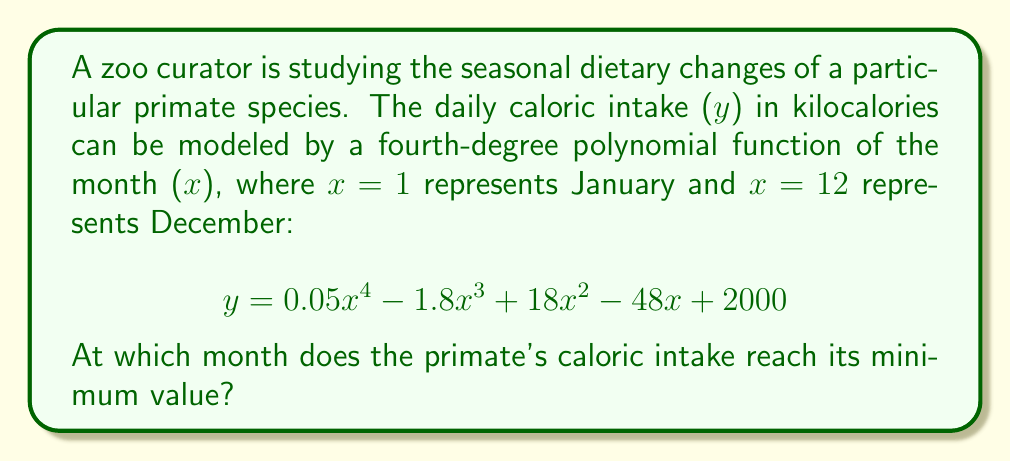Can you solve this math problem? To find the month when the caloric intake reaches its minimum, we need to follow these steps:

1) First, we need to find the derivative of the function:
   $$y' = 0.2x^3 - 5.4x^2 + 36x - 48$$

2) To find the critical points, we set y' = 0 and solve for x:
   $$0.2x^3 - 5.4x^2 + 36x - 48 = 0$$

3) This cubic equation is difficult to solve by hand, so we can use a graphing calculator or computer algebra system to find the roots. The roots are approximately:
   x ≈ 1.37, 5.62, and 20.01

4) Since we're only concerned with months 1-12, we can discard the solution 20.01.

5) To determine which of these critical points gives the minimum value, we can use the second derivative test:
   $$y'' = 0.6x^2 - 10.8x + 36$$

6) Evaluating y'' at x = 1.37 and x = 5.62:
   y''(1.37) ≈ 22.3 (positive, local minimum)
   y''(5.62) ≈ -11.7 (negative, local maximum)

7) Since we're looking for the minimum value, x ≈ 1.37 is our answer.

8) Rounding to the nearest whole month, this corresponds to February (month 2).
Answer: February (month 2) 